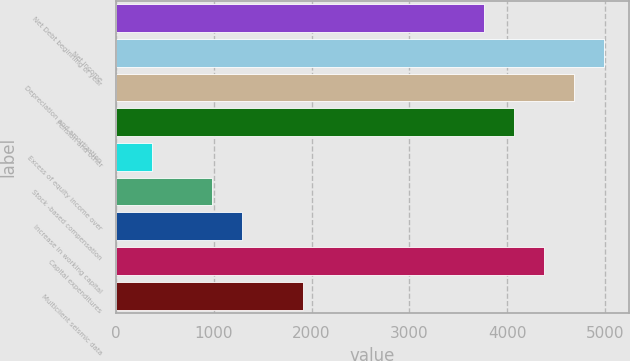Convert chart to OTSL. <chart><loc_0><loc_0><loc_500><loc_500><bar_chart><fcel>Net Debt beginning of year<fcel>Net income<fcel>Depreciation and amortization<fcel>Pension and other<fcel>Excess of equity income over<fcel>Stock -based compensation<fcel>Increase in working capital<fcel>Capital expenditures<fcel>Multiclient seismic data<nl><fcel>3758.6<fcel>4991.8<fcel>4683.5<fcel>4066.9<fcel>367.3<fcel>983.9<fcel>1292.2<fcel>4375.2<fcel>1908.8<nl></chart> 